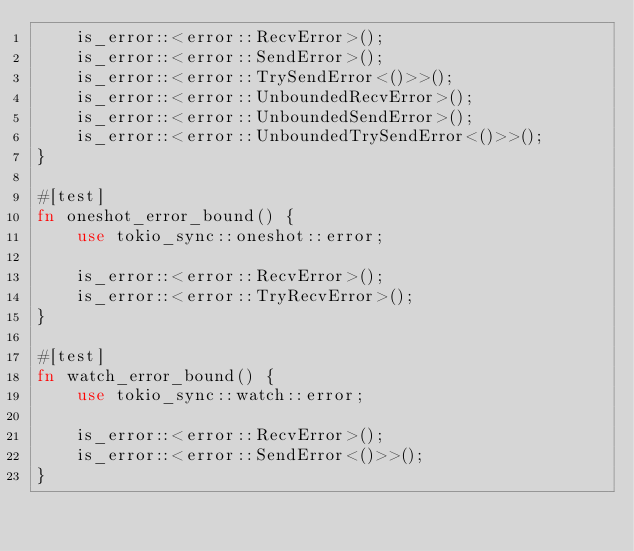Convert code to text. <code><loc_0><loc_0><loc_500><loc_500><_Rust_>    is_error::<error::RecvError>();
    is_error::<error::SendError>();
    is_error::<error::TrySendError<()>>();
    is_error::<error::UnboundedRecvError>();
    is_error::<error::UnboundedSendError>();
    is_error::<error::UnboundedTrySendError<()>>();
}

#[test]
fn oneshot_error_bound() {
    use tokio_sync::oneshot::error;

    is_error::<error::RecvError>();
    is_error::<error::TryRecvError>();
}

#[test]
fn watch_error_bound() {
    use tokio_sync::watch::error;

    is_error::<error::RecvError>();
    is_error::<error::SendError<()>>();
}
</code> 